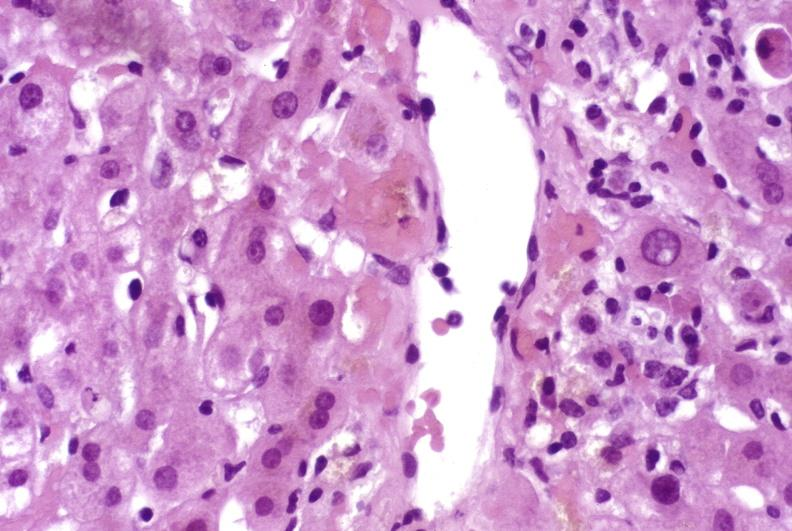s liver present?
Answer the question using a single word or phrase. Yes 